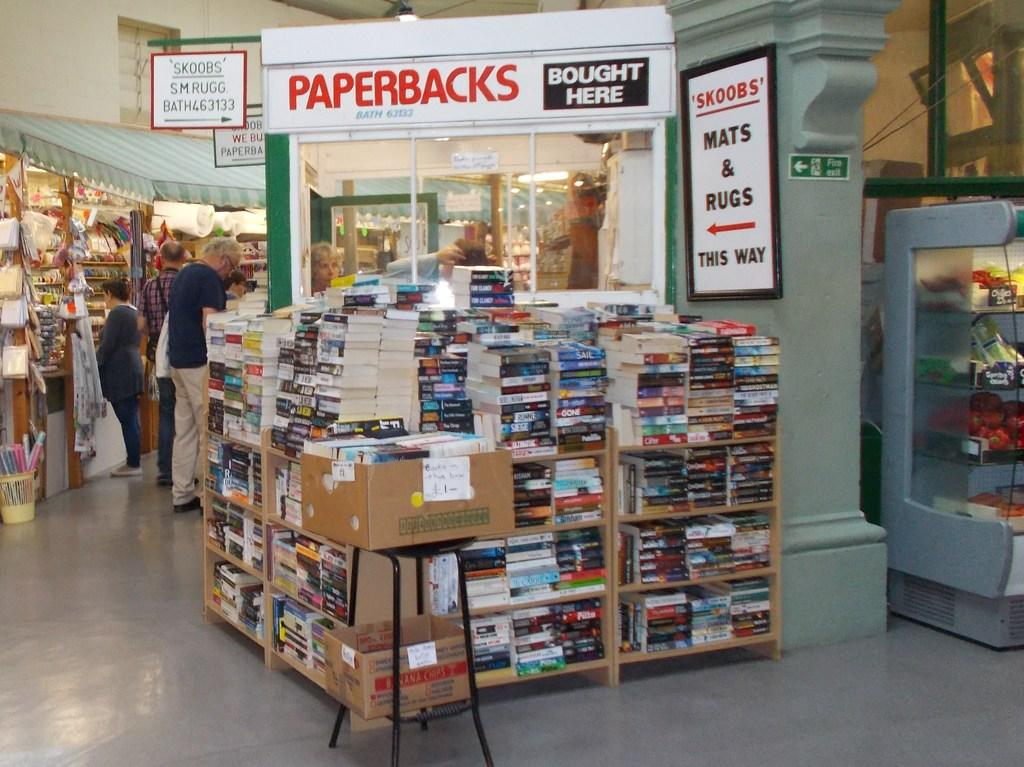<image>
Give a short and clear explanation of the subsequent image. Book display with many books below a Paperbacks sign 